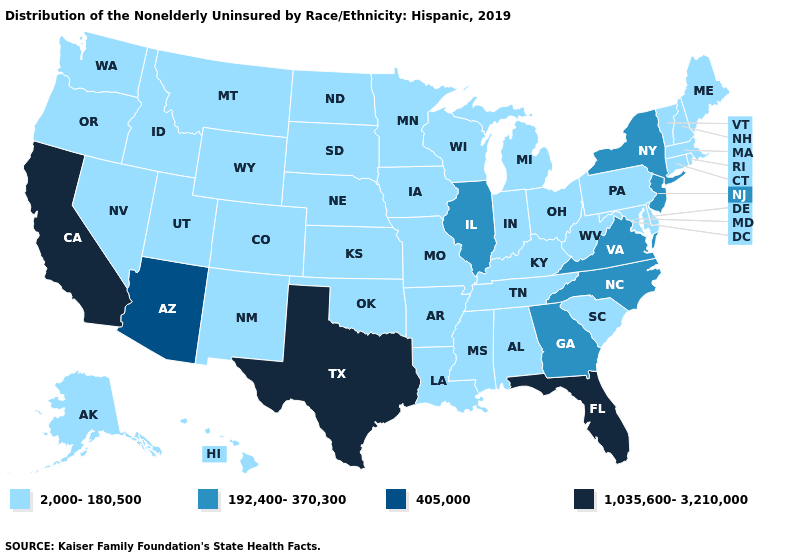Name the states that have a value in the range 1,035,600-3,210,000?
Give a very brief answer. California, Florida, Texas. What is the highest value in states that border North Dakota?
Give a very brief answer. 2,000-180,500. Does Iowa have the highest value in the USA?
Quick response, please. No. What is the value of Rhode Island?
Give a very brief answer. 2,000-180,500. What is the value of Nebraska?
Quick response, please. 2,000-180,500. Does the map have missing data?
Write a very short answer. No. Among the states that border New Mexico , which have the highest value?
Quick response, please. Texas. What is the lowest value in the West?
Be succinct. 2,000-180,500. Among the states that border North Carolina , does Tennessee have the lowest value?
Answer briefly. Yes. Does Florida have the highest value in the South?
Quick response, please. Yes. What is the value of Pennsylvania?
Short answer required. 2,000-180,500. What is the value of Mississippi?
Concise answer only. 2,000-180,500. Among the states that border Nebraska , which have the lowest value?
Quick response, please. Colorado, Iowa, Kansas, Missouri, South Dakota, Wyoming. What is the highest value in states that border Wisconsin?
Concise answer only. 192,400-370,300. 